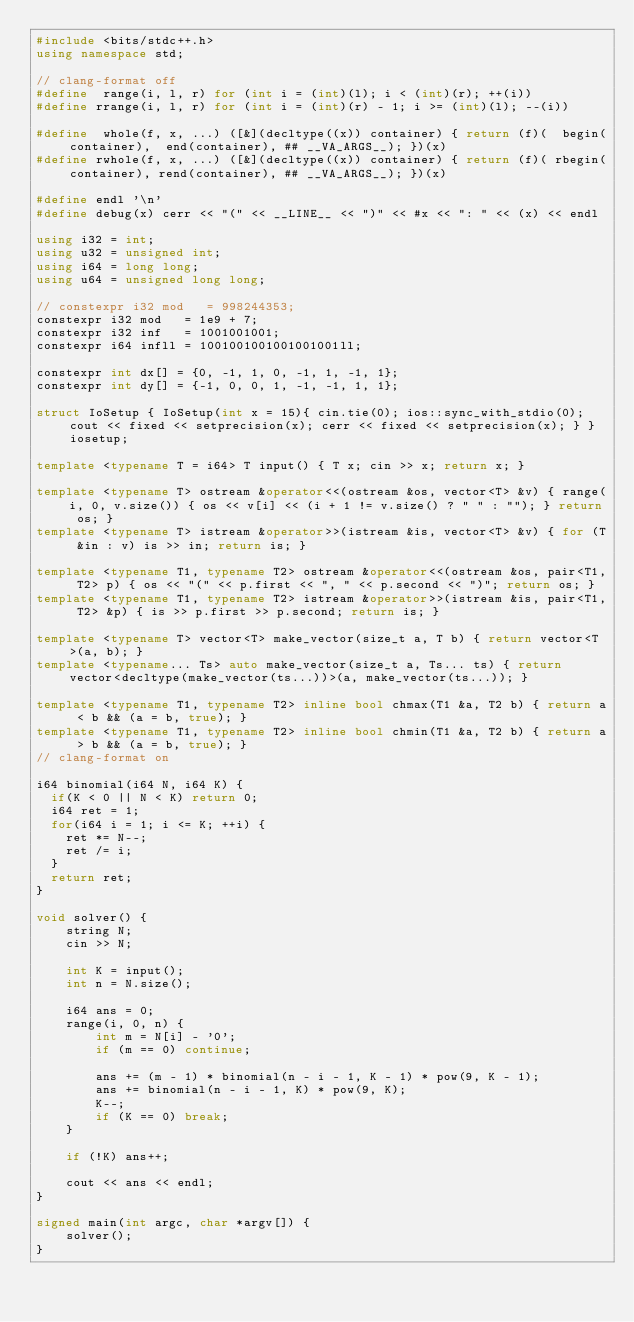Convert code to text. <code><loc_0><loc_0><loc_500><loc_500><_C++_>#include <bits/stdc++.h>
using namespace std;

// clang-format off
#define  range(i, l, r) for (int i = (int)(l); i < (int)(r); ++(i))
#define rrange(i, l, r) for (int i = (int)(r) - 1; i >= (int)(l); --(i))

#define  whole(f, x, ...) ([&](decltype((x)) container) { return (f)(  begin(container),  end(container), ## __VA_ARGS__); })(x)
#define rwhole(f, x, ...) ([&](decltype((x)) container) { return (f)( rbegin(container), rend(container), ## __VA_ARGS__); })(x)

#define endl '\n'
#define debug(x) cerr << "(" << __LINE__ << ")" << #x << ": " << (x) << endl

using i32 = int;
using u32 = unsigned int;
using i64 = long long;
using u64 = unsigned long long;

// constexpr i32 mod   = 998244353;
constexpr i32 mod   = 1e9 + 7;
constexpr i32 inf   = 1001001001;
constexpr i64 infll = 1001001001001001001ll;

constexpr int dx[] = {0, -1, 1, 0, -1, 1, -1, 1}; 
constexpr int dy[] = {-1, 0, 0, 1, -1, -1, 1, 1};

struct IoSetup { IoSetup(int x = 15){ cin.tie(0); ios::sync_with_stdio(0); cout << fixed << setprecision(x); cerr << fixed << setprecision(x); } } iosetup;

template <typename T = i64> T input() { T x; cin >> x; return x; }

template <typename T> ostream &operator<<(ostream &os, vector<T> &v) { range(i, 0, v.size()) { os << v[i] << (i + 1 != v.size() ? " " : ""); } return os; } 
template <typename T> istream &operator>>(istream &is, vector<T> &v) { for (T &in : v) is >> in; return is; }

template <typename T1, typename T2> ostream &operator<<(ostream &os, pair<T1, T2> p) { os << "(" << p.first << ", " << p.second << ")"; return os; }
template <typename T1, typename T2> istream &operator>>(istream &is, pair<T1, T2> &p) { is >> p.first >> p.second; return is; }

template <typename T> vector<T> make_vector(size_t a, T b) { return vector<T>(a, b); }
template <typename... Ts> auto make_vector(size_t a, Ts... ts) { return vector<decltype(make_vector(ts...))>(a, make_vector(ts...)); }

template <typename T1, typename T2> inline bool chmax(T1 &a, T2 b) { return a < b && (a = b, true); }
template <typename T1, typename T2> inline bool chmin(T1 &a, T2 b) { return a > b && (a = b, true); }
// clang-format on

i64 binomial(i64 N, i64 K) {
  if(K < 0 || N < K) return 0;
  i64 ret = 1;
  for(i64 i = 1; i <= K; ++i) {
    ret *= N--;
    ret /= i;
  }
  return ret;
}

void solver() {
    string N;
    cin >> N;
    
    int K = input();
    int n = N.size();

    i64 ans = 0;
    range(i, 0, n) {
        int m = N[i] - '0';
        if (m == 0) continue;

        ans += (m - 1) * binomial(n - i - 1, K - 1) * pow(9, K - 1);
        ans += binomial(n - i - 1, K) * pow(9, K);
        K--;
        if (K == 0) break;
    }

    if (!K) ans++;

    cout << ans << endl;
}

signed main(int argc, char *argv[]) {
    solver();
}
</code> 